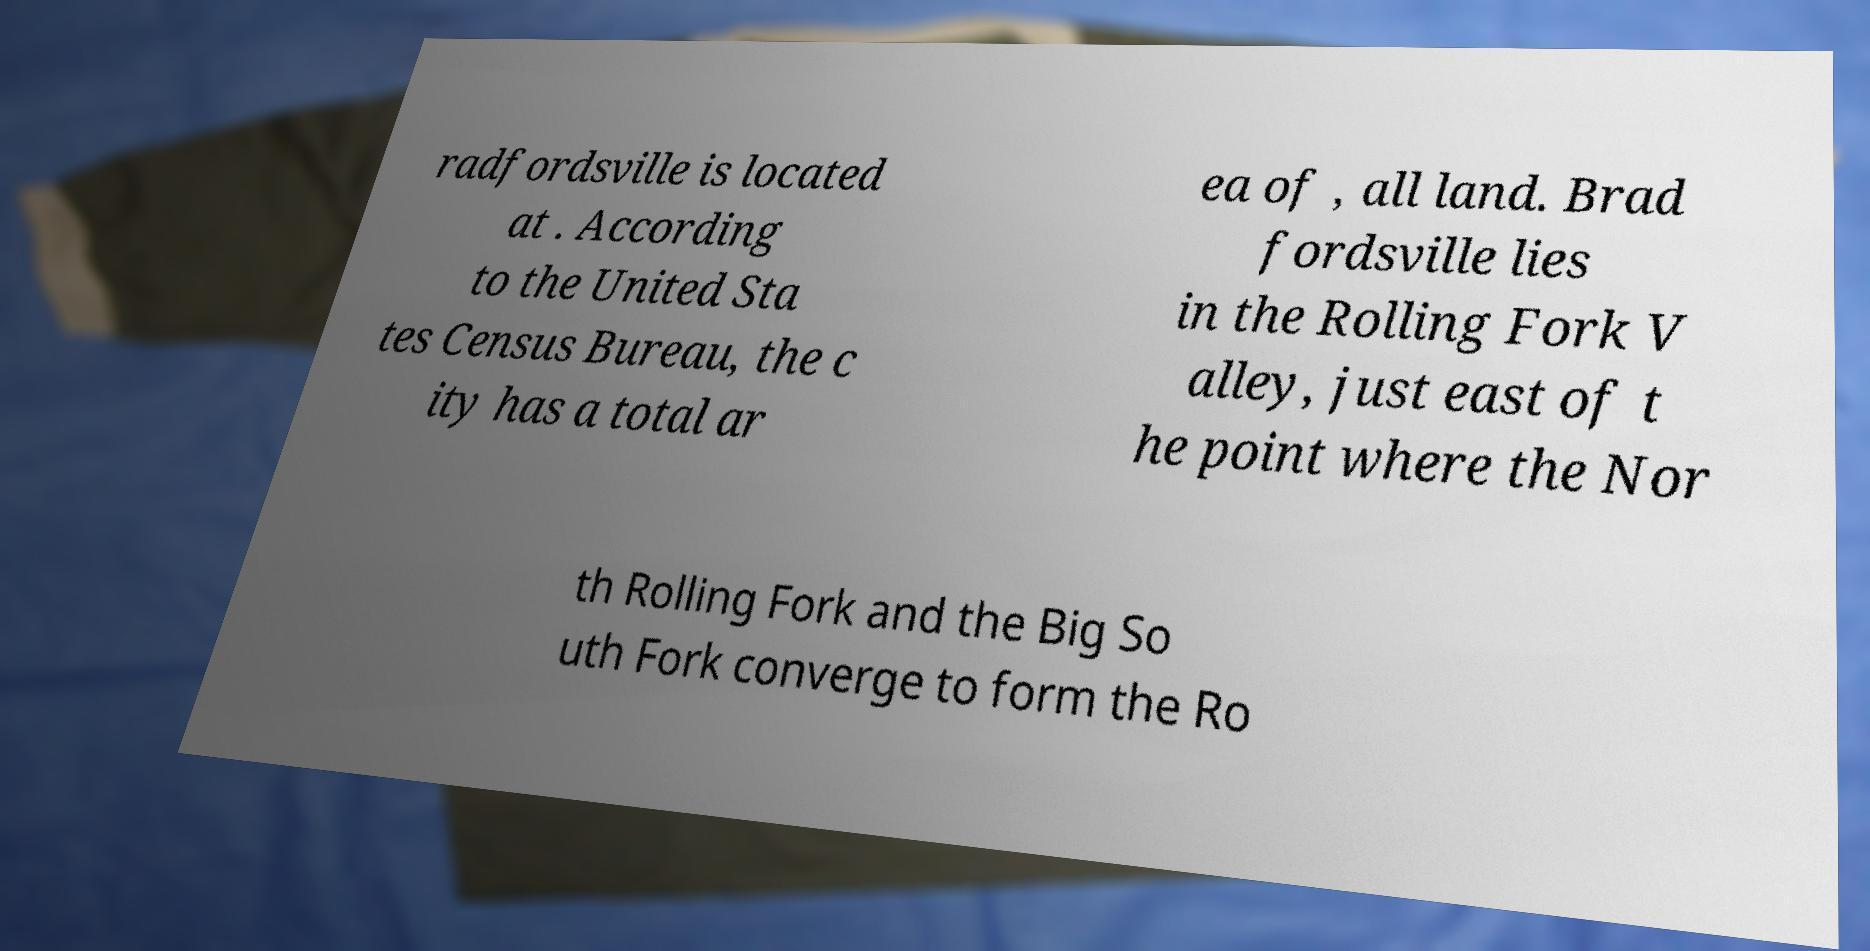I need the written content from this picture converted into text. Can you do that? radfordsville is located at . According to the United Sta tes Census Bureau, the c ity has a total ar ea of , all land. Brad fordsville lies in the Rolling Fork V alley, just east of t he point where the Nor th Rolling Fork and the Big So uth Fork converge to form the Ro 